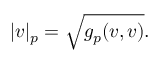<formula> <loc_0><loc_0><loc_500><loc_500>| v | _ { p } = { \sqrt { g _ { p } ( v , v ) } } .</formula> 